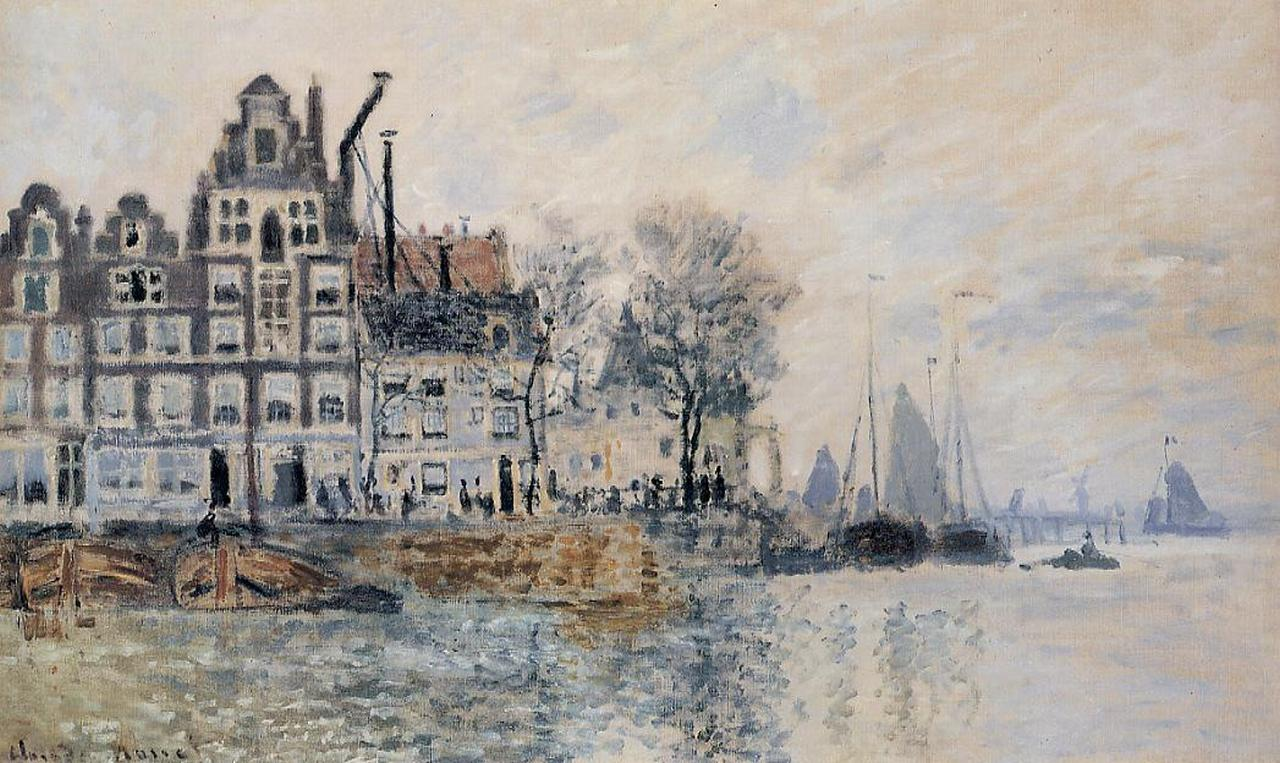If this scene was part of a storybook, what would the plot be? Set in a quaint, historic riverside city, the storybook would follow the adventures of a young artist named Clara. Clara dreams of capturing the soul of her city through her impressionist paintings. One day, while sketching by the river, she stumbles upon an old, intricately designed key hidden inside a tree hollow. Intrigued by its mysterious aura, she sets off on a journey to uncover its origins. Along her journey, Clara encounters various townsfolk, each with their own stories and wisdom, guiding her towards the key's ancient tale. The key is said to unlock a hidden, forgotten gallery filled with the works of long-lost artists from the city's golden age. However, legends speak of a guardian spirit who protects this gallery, and only a true artist can gain its favor. As Clara delves deeper into the mystery, she learns about the city's rich history and the profound connection between art and life. Her quest culminates in a dramatic encounter with the guardian spirit, where Clara must prove her artistic spirit to uncover the gallery and bring its forgotten beauty back to the present, forever changing the way the townsfolk see their own heritage. What if this painting came to life at night? Describe the scene. As the final rays of sunlight fade and the city’s lamps begin to twinkle, an enchanting transformation takes place. The river, previously calm, begins to shimmer with hues of gold and silver, reflecting the moonlight. The boats, once stationary, now glided silently over the water, their lanterns casting dancing shadows on the facades of the buildings. The buildings themselves seemed to sigh awake from their painted slumber, as delicate lights flickered in the windows and soft strains of music floated in the night air. Characters from history, dressed in period clothing, appeared on the streets, strolling arm in arm, engaged in lively conversation. The trees rustled softly, their leaves whispering secrets of the past. The entire cityscape, bathed in the magical glow of night, felt alive with the stories, dreams, and memories of all who had ever lived and loved there. The scene was an ethereal blend of reality and fantasy, where the boundaries of the painting dissolved into a living, breathing world, inviting all who witnessed it to step into its timeless embrace. 